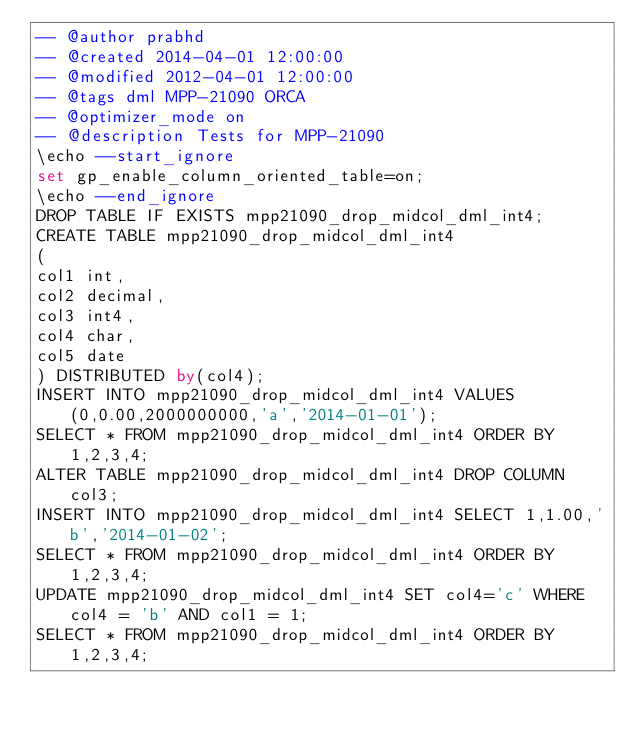<code> <loc_0><loc_0><loc_500><loc_500><_SQL_>-- @author prabhd 
-- @created 2014-04-01 12:00:00
-- @modified 2012-04-01 12:00:00
-- @tags dml MPP-21090 ORCA
-- @optimizer_mode on	
-- @description Tests for MPP-21090
\echo --start_ignore
set gp_enable_column_oriented_table=on;
\echo --end_ignore
DROP TABLE IF EXISTS mpp21090_drop_midcol_dml_int4;
CREATE TABLE mpp21090_drop_midcol_dml_int4
(
col1 int,
col2 decimal,
col3 int4,
col4 char,
col5 date
) DISTRIBUTED by(col4);
INSERT INTO mpp21090_drop_midcol_dml_int4 VALUES(0,0.00,2000000000,'a','2014-01-01');
SELECT * FROM mpp21090_drop_midcol_dml_int4 ORDER BY 1,2,3,4;
ALTER TABLE mpp21090_drop_midcol_dml_int4 DROP COLUMN col3;
INSERT INTO mpp21090_drop_midcol_dml_int4 SELECT 1,1.00,'b','2014-01-02';
SELECT * FROM mpp21090_drop_midcol_dml_int4 ORDER BY 1,2,3,4;
UPDATE mpp21090_drop_midcol_dml_int4 SET col4='c' WHERE col4 = 'b' AND col1 = 1;
SELECT * FROM mpp21090_drop_midcol_dml_int4 ORDER BY 1,2,3,4;
</code> 